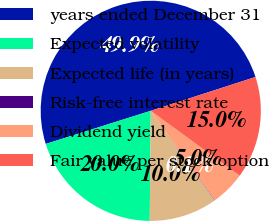<chart> <loc_0><loc_0><loc_500><loc_500><pie_chart><fcel>years ended December 31<fcel>Expected volatility<fcel>Expected life (in years)<fcel>Risk-free interest rate<fcel>Dividend yield<fcel>Fair value per stock option<nl><fcel>49.89%<fcel>19.99%<fcel>10.02%<fcel>0.05%<fcel>5.04%<fcel>15.01%<nl></chart> 